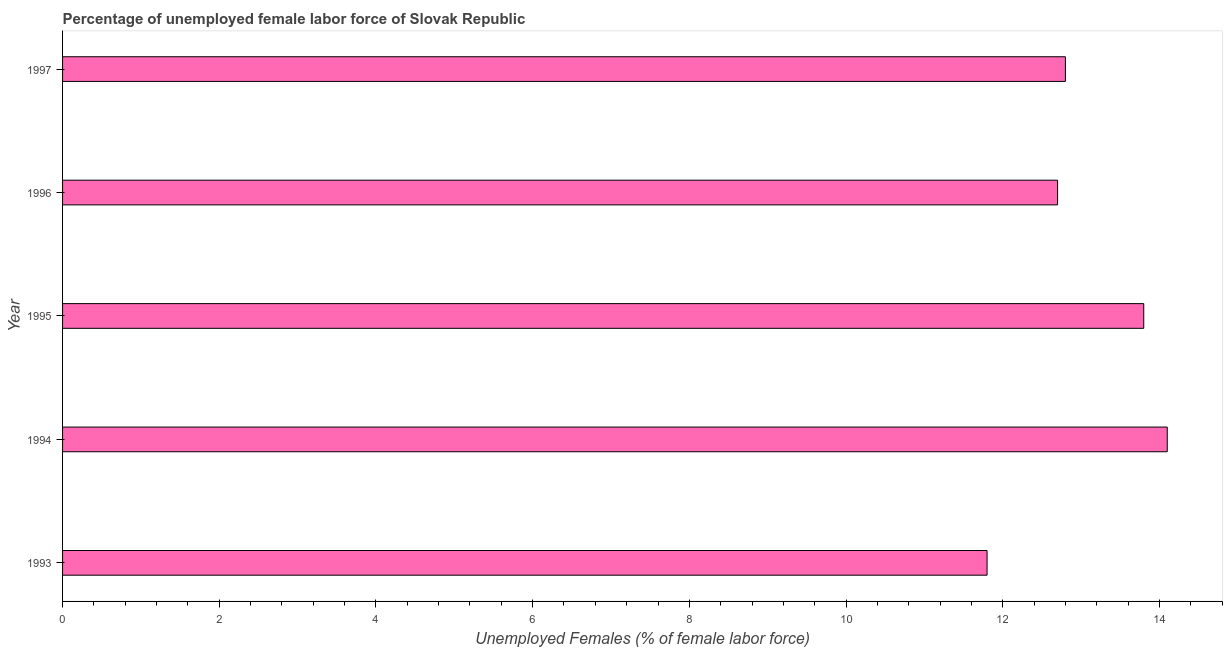Does the graph contain grids?
Your answer should be very brief. No. What is the title of the graph?
Make the answer very short. Percentage of unemployed female labor force of Slovak Republic. What is the label or title of the X-axis?
Ensure brevity in your answer.  Unemployed Females (% of female labor force). What is the total unemployed female labour force in 1993?
Give a very brief answer. 11.8. Across all years, what is the maximum total unemployed female labour force?
Offer a very short reply. 14.1. Across all years, what is the minimum total unemployed female labour force?
Offer a terse response. 11.8. What is the sum of the total unemployed female labour force?
Make the answer very short. 65.2. What is the average total unemployed female labour force per year?
Offer a terse response. 13.04. What is the median total unemployed female labour force?
Offer a terse response. 12.8. What is the ratio of the total unemployed female labour force in 1994 to that in 1997?
Give a very brief answer. 1.1. What is the difference between the highest and the lowest total unemployed female labour force?
Your response must be concise. 2.3. How many bars are there?
Your answer should be very brief. 5. How many years are there in the graph?
Make the answer very short. 5. Are the values on the major ticks of X-axis written in scientific E-notation?
Make the answer very short. No. What is the Unemployed Females (% of female labor force) of 1993?
Your answer should be very brief. 11.8. What is the Unemployed Females (% of female labor force) of 1994?
Make the answer very short. 14.1. What is the Unemployed Females (% of female labor force) in 1995?
Your answer should be compact. 13.8. What is the Unemployed Females (% of female labor force) of 1996?
Ensure brevity in your answer.  12.7. What is the Unemployed Females (% of female labor force) in 1997?
Keep it short and to the point. 12.8. What is the difference between the Unemployed Females (% of female labor force) in 1993 and 1995?
Your answer should be compact. -2. What is the difference between the Unemployed Females (% of female labor force) in 1993 and 1996?
Offer a very short reply. -0.9. What is the difference between the Unemployed Females (% of female labor force) in 1995 and 1996?
Offer a terse response. 1.1. What is the difference between the Unemployed Females (% of female labor force) in 1996 and 1997?
Make the answer very short. -0.1. What is the ratio of the Unemployed Females (% of female labor force) in 1993 to that in 1994?
Make the answer very short. 0.84. What is the ratio of the Unemployed Females (% of female labor force) in 1993 to that in 1995?
Keep it short and to the point. 0.85. What is the ratio of the Unemployed Females (% of female labor force) in 1993 to that in 1996?
Your response must be concise. 0.93. What is the ratio of the Unemployed Females (% of female labor force) in 1993 to that in 1997?
Provide a short and direct response. 0.92. What is the ratio of the Unemployed Females (% of female labor force) in 1994 to that in 1996?
Offer a very short reply. 1.11. What is the ratio of the Unemployed Females (% of female labor force) in 1994 to that in 1997?
Your answer should be very brief. 1.1. What is the ratio of the Unemployed Females (% of female labor force) in 1995 to that in 1996?
Your response must be concise. 1.09. What is the ratio of the Unemployed Females (% of female labor force) in 1995 to that in 1997?
Provide a short and direct response. 1.08. 